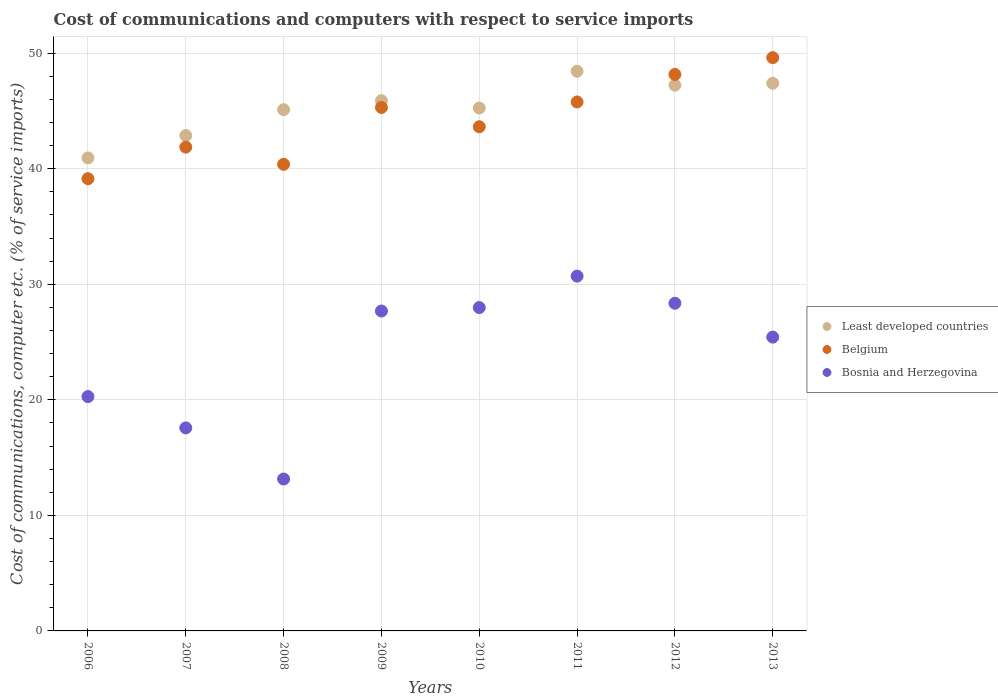Is the number of dotlines equal to the number of legend labels?
Your answer should be compact. Yes. What is the cost of communications and computers in Bosnia and Herzegovina in 2012?
Give a very brief answer. 28.36. Across all years, what is the maximum cost of communications and computers in Bosnia and Herzegovina?
Keep it short and to the point. 30.7. Across all years, what is the minimum cost of communications and computers in Bosnia and Herzegovina?
Your answer should be compact. 13.15. In which year was the cost of communications and computers in Bosnia and Herzegovina minimum?
Your response must be concise. 2008. What is the total cost of communications and computers in Bosnia and Herzegovina in the graph?
Your answer should be very brief. 191.15. What is the difference between the cost of communications and computers in Belgium in 2007 and that in 2011?
Provide a succinct answer. -3.91. What is the difference between the cost of communications and computers in Least developed countries in 2006 and the cost of communications and computers in Belgium in 2008?
Keep it short and to the point. 0.56. What is the average cost of communications and computers in Least developed countries per year?
Offer a very short reply. 45.39. In the year 2006, what is the difference between the cost of communications and computers in Least developed countries and cost of communications and computers in Bosnia and Herzegovina?
Ensure brevity in your answer.  20.66. What is the ratio of the cost of communications and computers in Bosnia and Herzegovina in 2007 to that in 2009?
Keep it short and to the point. 0.63. What is the difference between the highest and the second highest cost of communications and computers in Belgium?
Your answer should be compact. 1.46. What is the difference between the highest and the lowest cost of communications and computers in Bosnia and Herzegovina?
Give a very brief answer. 17.56. In how many years, is the cost of communications and computers in Least developed countries greater than the average cost of communications and computers in Least developed countries taken over all years?
Your answer should be very brief. 4. Is the sum of the cost of communications and computers in Belgium in 2008 and 2013 greater than the maximum cost of communications and computers in Least developed countries across all years?
Provide a succinct answer. Yes. Is it the case that in every year, the sum of the cost of communications and computers in Bosnia and Herzegovina and cost of communications and computers in Belgium  is greater than the cost of communications and computers in Least developed countries?
Give a very brief answer. Yes. Does the cost of communications and computers in Belgium monotonically increase over the years?
Give a very brief answer. No. Are the values on the major ticks of Y-axis written in scientific E-notation?
Offer a very short reply. No. Does the graph contain grids?
Your answer should be compact. Yes. Where does the legend appear in the graph?
Keep it short and to the point. Center right. How are the legend labels stacked?
Make the answer very short. Vertical. What is the title of the graph?
Provide a short and direct response. Cost of communications and computers with respect to service imports. Does "Gabon" appear as one of the legend labels in the graph?
Your answer should be compact. No. What is the label or title of the Y-axis?
Your answer should be compact. Cost of communications, computer etc. (% of service imports). What is the Cost of communications, computer etc. (% of service imports) in Least developed countries in 2006?
Keep it short and to the point. 40.94. What is the Cost of communications, computer etc. (% of service imports) of Belgium in 2006?
Offer a terse response. 39.14. What is the Cost of communications, computer etc. (% of service imports) of Bosnia and Herzegovina in 2006?
Your answer should be very brief. 20.28. What is the Cost of communications, computer etc. (% of service imports) in Least developed countries in 2007?
Make the answer very short. 42.87. What is the Cost of communications, computer etc. (% of service imports) of Belgium in 2007?
Give a very brief answer. 41.87. What is the Cost of communications, computer etc. (% of service imports) of Bosnia and Herzegovina in 2007?
Keep it short and to the point. 17.57. What is the Cost of communications, computer etc. (% of service imports) in Least developed countries in 2008?
Make the answer very short. 45.11. What is the Cost of communications, computer etc. (% of service imports) of Belgium in 2008?
Offer a very short reply. 40.38. What is the Cost of communications, computer etc. (% of service imports) of Bosnia and Herzegovina in 2008?
Your response must be concise. 13.15. What is the Cost of communications, computer etc. (% of service imports) in Least developed countries in 2009?
Your answer should be very brief. 45.89. What is the Cost of communications, computer etc. (% of service imports) of Belgium in 2009?
Offer a very short reply. 45.3. What is the Cost of communications, computer etc. (% of service imports) in Bosnia and Herzegovina in 2009?
Offer a terse response. 27.68. What is the Cost of communications, computer etc. (% of service imports) of Least developed countries in 2010?
Provide a short and direct response. 45.25. What is the Cost of communications, computer etc. (% of service imports) in Belgium in 2010?
Provide a succinct answer. 43.63. What is the Cost of communications, computer etc. (% of service imports) of Bosnia and Herzegovina in 2010?
Your answer should be very brief. 27.98. What is the Cost of communications, computer etc. (% of service imports) in Least developed countries in 2011?
Offer a very short reply. 48.43. What is the Cost of communications, computer etc. (% of service imports) in Belgium in 2011?
Provide a succinct answer. 45.78. What is the Cost of communications, computer etc. (% of service imports) of Bosnia and Herzegovina in 2011?
Keep it short and to the point. 30.7. What is the Cost of communications, computer etc. (% of service imports) of Least developed countries in 2012?
Ensure brevity in your answer.  47.23. What is the Cost of communications, computer etc. (% of service imports) in Belgium in 2012?
Provide a succinct answer. 48.16. What is the Cost of communications, computer etc. (% of service imports) in Bosnia and Herzegovina in 2012?
Offer a terse response. 28.36. What is the Cost of communications, computer etc. (% of service imports) of Least developed countries in 2013?
Offer a very short reply. 47.39. What is the Cost of communications, computer etc. (% of service imports) in Belgium in 2013?
Offer a very short reply. 49.61. What is the Cost of communications, computer etc. (% of service imports) in Bosnia and Herzegovina in 2013?
Make the answer very short. 25.43. Across all years, what is the maximum Cost of communications, computer etc. (% of service imports) of Least developed countries?
Your answer should be very brief. 48.43. Across all years, what is the maximum Cost of communications, computer etc. (% of service imports) in Belgium?
Provide a succinct answer. 49.61. Across all years, what is the maximum Cost of communications, computer etc. (% of service imports) of Bosnia and Herzegovina?
Your answer should be compact. 30.7. Across all years, what is the minimum Cost of communications, computer etc. (% of service imports) of Least developed countries?
Make the answer very short. 40.94. Across all years, what is the minimum Cost of communications, computer etc. (% of service imports) of Belgium?
Your response must be concise. 39.14. Across all years, what is the minimum Cost of communications, computer etc. (% of service imports) in Bosnia and Herzegovina?
Ensure brevity in your answer.  13.15. What is the total Cost of communications, computer etc. (% of service imports) of Least developed countries in the graph?
Your response must be concise. 363.11. What is the total Cost of communications, computer etc. (% of service imports) in Belgium in the graph?
Your response must be concise. 353.86. What is the total Cost of communications, computer etc. (% of service imports) of Bosnia and Herzegovina in the graph?
Your answer should be compact. 191.15. What is the difference between the Cost of communications, computer etc. (% of service imports) in Least developed countries in 2006 and that in 2007?
Your response must be concise. -1.93. What is the difference between the Cost of communications, computer etc. (% of service imports) in Belgium in 2006 and that in 2007?
Offer a terse response. -2.73. What is the difference between the Cost of communications, computer etc. (% of service imports) of Bosnia and Herzegovina in 2006 and that in 2007?
Ensure brevity in your answer.  2.71. What is the difference between the Cost of communications, computer etc. (% of service imports) in Least developed countries in 2006 and that in 2008?
Your response must be concise. -4.17. What is the difference between the Cost of communications, computer etc. (% of service imports) in Belgium in 2006 and that in 2008?
Your response must be concise. -1.25. What is the difference between the Cost of communications, computer etc. (% of service imports) of Bosnia and Herzegovina in 2006 and that in 2008?
Your answer should be compact. 7.13. What is the difference between the Cost of communications, computer etc. (% of service imports) in Least developed countries in 2006 and that in 2009?
Keep it short and to the point. -4.95. What is the difference between the Cost of communications, computer etc. (% of service imports) of Belgium in 2006 and that in 2009?
Offer a terse response. -6.17. What is the difference between the Cost of communications, computer etc. (% of service imports) in Bosnia and Herzegovina in 2006 and that in 2009?
Ensure brevity in your answer.  -7.4. What is the difference between the Cost of communications, computer etc. (% of service imports) in Least developed countries in 2006 and that in 2010?
Offer a terse response. -4.31. What is the difference between the Cost of communications, computer etc. (% of service imports) of Belgium in 2006 and that in 2010?
Your response must be concise. -4.5. What is the difference between the Cost of communications, computer etc. (% of service imports) in Bosnia and Herzegovina in 2006 and that in 2010?
Your response must be concise. -7.7. What is the difference between the Cost of communications, computer etc. (% of service imports) of Least developed countries in 2006 and that in 2011?
Provide a short and direct response. -7.5. What is the difference between the Cost of communications, computer etc. (% of service imports) in Belgium in 2006 and that in 2011?
Offer a very short reply. -6.64. What is the difference between the Cost of communications, computer etc. (% of service imports) in Bosnia and Herzegovina in 2006 and that in 2011?
Your response must be concise. -10.42. What is the difference between the Cost of communications, computer etc. (% of service imports) of Least developed countries in 2006 and that in 2012?
Make the answer very short. -6.29. What is the difference between the Cost of communications, computer etc. (% of service imports) in Belgium in 2006 and that in 2012?
Offer a terse response. -9.02. What is the difference between the Cost of communications, computer etc. (% of service imports) in Bosnia and Herzegovina in 2006 and that in 2012?
Provide a short and direct response. -8.08. What is the difference between the Cost of communications, computer etc. (% of service imports) of Least developed countries in 2006 and that in 2013?
Keep it short and to the point. -6.46. What is the difference between the Cost of communications, computer etc. (% of service imports) of Belgium in 2006 and that in 2013?
Offer a terse response. -10.48. What is the difference between the Cost of communications, computer etc. (% of service imports) of Bosnia and Herzegovina in 2006 and that in 2013?
Ensure brevity in your answer.  -5.15. What is the difference between the Cost of communications, computer etc. (% of service imports) of Least developed countries in 2007 and that in 2008?
Give a very brief answer. -2.24. What is the difference between the Cost of communications, computer etc. (% of service imports) of Belgium in 2007 and that in 2008?
Ensure brevity in your answer.  1.49. What is the difference between the Cost of communications, computer etc. (% of service imports) in Bosnia and Herzegovina in 2007 and that in 2008?
Keep it short and to the point. 4.42. What is the difference between the Cost of communications, computer etc. (% of service imports) of Least developed countries in 2007 and that in 2009?
Make the answer very short. -3.02. What is the difference between the Cost of communications, computer etc. (% of service imports) in Belgium in 2007 and that in 2009?
Your answer should be very brief. -3.43. What is the difference between the Cost of communications, computer etc. (% of service imports) of Bosnia and Herzegovina in 2007 and that in 2009?
Offer a very short reply. -10.11. What is the difference between the Cost of communications, computer etc. (% of service imports) of Least developed countries in 2007 and that in 2010?
Provide a short and direct response. -2.38. What is the difference between the Cost of communications, computer etc. (% of service imports) of Belgium in 2007 and that in 2010?
Your response must be concise. -1.76. What is the difference between the Cost of communications, computer etc. (% of service imports) of Bosnia and Herzegovina in 2007 and that in 2010?
Offer a very short reply. -10.41. What is the difference between the Cost of communications, computer etc. (% of service imports) of Least developed countries in 2007 and that in 2011?
Your answer should be compact. -5.56. What is the difference between the Cost of communications, computer etc. (% of service imports) of Belgium in 2007 and that in 2011?
Make the answer very short. -3.91. What is the difference between the Cost of communications, computer etc. (% of service imports) of Bosnia and Herzegovina in 2007 and that in 2011?
Make the answer very short. -13.13. What is the difference between the Cost of communications, computer etc. (% of service imports) in Least developed countries in 2007 and that in 2012?
Ensure brevity in your answer.  -4.36. What is the difference between the Cost of communications, computer etc. (% of service imports) in Belgium in 2007 and that in 2012?
Offer a terse response. -6.29. What is the difference between the Cost of communications, computer etc. (% of service imports) in Bosnia and Herzegovina in 2007 and that in 2012?
Provide a short and direct response. -10.79. What is the difference between the Cost of communications, computer etc. (% of service imports) of Least developed countries in 2007 and that in 2013?
Make the answer very short. -4.52. What is the difference between the Cost of communications, computer etc. (% of service imports) of Belgium in 2007 and that in 2013?
Your response must be concise. -7.74. What is the difference between the Cost of communications, computer etc. (% of service imports) in Bosnia and Herzegovina in 2007 and that in 2013?
Provide a short and direct response. -7.86. What is the difference between the Cost of communications, computer etc. (% of service imports) in Least developed countries in 2008 and that in 2009?
Give a very brief answer. -0.78. What is the difference between the Cost of communications, computer etc. (% of service imports) of Belgium in 2008 and that in 2009?
Keep it short and to the point. -4.92. What is the difference between the Cost of communications, computer etc. (% of service imports) in Bosnia and Herzegovina in 2008 and that in 2009?
Provide a succinct answer. -14.54. What is the difference between the Cost of communications, computer etc. (% of service imports) of Least developed countries in 2008 and that in 2010?
Your response must be concise. -0.14. What is the difference between the Cost of communications, computer etc. (% of service imports) in Belgium in 2008 and that in 2010?
Keep it short and to the point. -3.25. What is the difference between the Cost of communications, computer etc. (% of service imports) of Bosnia and Herzegovina in 2008 and that in 2010?
Provide a succinct answer. -14.84. What is the difference between the Cost of communications, computer etc. (% of service imports) in Least developed countries in 2008 and that in 2011?
Offer a very short reply. -3.32. What is the difference between the Cost of communications, computer etc. (% of service imports) of Belgium in 2008 and that in 2011?
Give a very brief answer. -5.39. What is the difference between the Cost of communications, computer etc. (% of service imports) of Bosnia and Herzegovina in 2008 and that in 2011?
Provide a short and direct response. -17.56. What is the difference between the Cost of communications, computer etc. (% of service imports) in Least developed countries in 2008 and that in 2012?
Offer a very short reply. -2.12. What is the difference between the Cost of communications, computer etc. (% of service imports) of Belgium in 2008 and that in 2012?
Make the answer very short. -7.77. What is the difference between the Cost of communications, computer etc. (% of service imports) in Bosnia and Herzegovina in 2008 and that in 2012?
Ensure brevity in your answer.  -15.21. What is the difference between the Cost of communications, computer etc. (% of service imports) in Least developed countries in 2008 and that in 2013?
Give a very brief answer. -2.29. What is the difference between the Cost of communications, computer etc. (% of service imports) in Belgium in 2008 and that in 2013?
Your response must be concise. -9.23. What is the difference between the Cost of communications, computer etc. (% of service imports) in Bosnia and Herzegovina in 2008 and that in 2013?
Offer a terse response. -12.28. What is the difference between the Cost of communications, computer etc. (% of service imports) of Least developed countries in 2009 and that in 2010?
Offer a terse response. 0.64. What is the difference between the Cost of communications, computer etc. (% of service imports) of Belgium in 2009 and that in 2010?
Provide a succinct answer. 1.67. What is the difference between the Cost of communications, computer etc. (% of service imports) in Bosnia and Herzegovina in 2009 and that in 2010?
Your response must be concise. -0.3. What is the difference between the Cost of communications, computer etc. (% of service imports) in Least developed countries in 2009 and that in 2011?
Offer a terse response. -2.55. What is the difference between the Cost of communications, computer etc. (% of service imports) in Belgium in 2009 and that in 2011?
Your answer should be compact. -0.47. What is the difference between the Cost of communications, computer etc. (% of service imports) in Bosnia and Herzegovina in 2009 and that in 2011?
Provide a short and direct response. -3.02. What is the difference between the Cost of communications, computer etc. (% of service imports) of Least developed countries in 2009 and that in 2012?
Give a very brief answer. -1.34. What is the difference between the Cost of communications, computer etc. (% of service imports) in Belgium in 2009 and that in 2012?
Provide a short and direct response. -2.85. What is the difference between the Cost of communications, computer etc. (% of service imports) in Bosnia and Herzegovina in 2009 and that in 2012?
Your response must be concise. -0.67. What is the difference between the Cost of communications, computer etc. (% of service imports) of Least developed countries in 2009 and that in 2013?
Your answer should be compact. -1.51. What is the difference between the Cost of communications, computer etc. (% of service imports) of Belgium in 2009 and that in 2013?
Keep it short and to the point. -4.31. What is the difference between the Cost of communications, computer etc. (% of service imports) of Bosnia and Herzegovina in 2009 and that in 2013?
Ensure brevity in your answer.  2.26. What is the difference between the Cost of communications, computer etc. (% of service imports) of Least developed countries in 2010 and that in 2011?
Ensure brevity in your answer.  -3.18. What is the difference between the Cost of communications, computer etc. (% of service imports) in Belgium in 2010 and that in 2011?
Keep it short and to the point. -2.14. What is the difference between the Cost of communications, computer etc. (% of service imports) of Bosnia and Herzegovina in 2010 and that in 2011?
Keep it short and to the point. -2.72. What is the difference between the Cost of communications, computer etc. (% of service imports) in Least developed countries in 2010 and that in 2012?
Keep it short and to the point. -1.98. What is the difference between the Cost of communications, computer etc. (% of service imports) in Belgium in 2010 and that in 2012?
Give a very brief answer. -4.52. What is the difference between the Cost of communications, computer etc. (% of service imports) of Bosnia and Herzegovina in 2010 and that in 2012?
Your answer should be compact. -0.37. What is the difference between the Cost of communications, computer etc. (% of service imports) in Least developed countries in 2010 and that in 2013?
Offer a very short reply. -2.14. What is the difference between the Cost of communications, computer etc. (% of service imports) in Belgium in 2010 and that in 2013?
Ensure brevity in your answer.  -5.98. What is the difference between the Cost of communications, computer etc. (% of service imports) in Bosnia and Herzegovina in 2010 and that in 2013?
Your answer should be very brief. 2.55. What is the difference between the Cost of communications, computer etc. (% of service imports) of Least developed countries in 2011 and that in 2012?
Ensure brevity in your answer.  1.21. What is the difference between the Cost of communications, computer etc. (% of service imports) of Belgium in 2011 and that in 2012?
Provide a succinct answer. -2.38. What is the difference between the Cost of communications, computer etc. (% of service imports) of Bosnia and Herzegovina in 2011 and that in 2012?
Your answer should be compact. 2.35. What is the difference between the Cost of communications, computer etc. (% of service imports) in Least developed countries in 2011 and that in 2013?
Your response must be concise. 1.04. What is the difference between the Cost of communications, computer etc. (% of service imports) in Belgium in 2011 and that in 2013?
Provide a succinct answer. -3.84. What is the difference between the Cost of communications, computer etc. (% of service imports) in Bosnia and Herzegovina in 2011 and that in 2013?
Offer a terse response. 5.28. What is the difference between the Cost of communications, computer etc. (% of service imports) in Least developed countries in 2012 and that in 2013?
Offer a terse response. -0.17. What is the difference between the Cost of communications, computer etc. (% of service imports) of Belgium in 2012 and that in 2013?
Your answer should be compact. -1.46. What is the difference between the Cost of communications, computer etc. (% of service imports) of Bosnia and Herzegovina in 2012 and that in 2013?
Your response must be concise. 2.93. What is the difference between the Cost of communications, computer etc. (% of service imports) in Least developed countries in 2006 and the Cost of communications, computer etc. (% of service imports) in Belgium in 2007?
Your response must be concise. -0.93. What is the difference between the Cost of communications, computer etc. (% of service imports) of Least developed countries in 2006 and the Cost of communications, computer etc. (% of service imports) of Bosnia and Herzegovina in 2007?
Ensure brevity in your answer.  23.37. What is the difference between the Cost of communications, computer etc. (% of service imports) in Belgium in 2006 and the Cost of communications, computer etc. (% of service imports) in Bosnia and Herzegovina in 2007?
Provide a succinct answer. 21.57. What is the difference between the Cost of communications, computer etc. (% of service imports) of Least developed countries in 2006 and the Cost of communications, computer etc. (% of service imports) of Belgium in 2008?
Keep it short and to the point. 0.56. What is the difference between the Cost of communications, computer etc. (% of service imports) in Least developed countries in 2006 and the Cost of communications, computer etc. (% of service imports) in Bosnia and Herzegovina in 2008?
Provide a short and direct response. 27.79. What is the difference between the Cost of communications, computer etc. (% of service imports) of Belgium in 2006 and the Cost of communications, computer etc. (% of service imports) of Bosnia and Herzegovina in 2008?
Provide a succinct answer. 25.99. What is the difference between the Cost of communications, computer etc. (% of service imports) of Least developed countries in 2006 and the Cost of communications, computer etc. (% of service imports) of Belgium in 2009?
Your answer should be compact. -4.36. What is the difference between the Cost of communications, computer etc. (% of service imports) of Least developed countries in 2006 and the Cost of communications, computer etc. (% of service imports) of Bosnia and Herzegovina in 2009?
Give a very brief answer. 13.25. What is the difference between the Cost of communications, computer etc. (% of service imports) in Belgium in 2006 and the Cost of communications, computer etc. (% of service imports) in Bosnia and Herzegovina in 2009?
Make the answer very short. 11.45. What is the difference between the Cost of communications, computer etc. (% of service imports) in Least developed countries in 2006 and the Cost of communications, computer etc. (% of service imports) in Belgium in 2010?
Your answer should be compact. -2.69. What is the difference between the Cost of communications, computer etc. (% of service imports) of Least developed countries in 2006 and the Cost of communications, computer etc. (% of service imports) of Bosnia and Herzegovina in 2010?
Provide a short and direct response. 12.96. What is the difference between the Cost of communications, computer etc. (% of service imports) in Belgium in 2006 and the Cost of communications, computer etc. (% of service imports) in Bosnia and Herzegovina in 2010?
Offer a terse response. 11.15. What is the difference between the Cost of communications, computer etc. (% of service imports) of Least developed countries in 2006 and the Cost of communications, computer etc. (% of service imports) of Belgium in 2011?
Keep it short and to the point. -4.84. What is the difference between the Cost of communications, computer etc. (% of service imports) of Least developed countries in 2006 and the Cost of communications, computer etc. (% of service imports) of Bosnia and Herzegovina in 2011?
Give a very brief answer. 10.23. What is the difference between the Cost of communications, computer etc. (% of service imports) in Belgium in 2006 and the Cost of communications, computer etc. (% of service imports) in Bosnia and Herzegovina in 2011?
Ensure brevity in your answer.  8.43. What is the difference between the Cost of communications, computer etc. (% of service imports) in Least developed countries in 2006 and the Cost of communications, computer etc. (% of service imports) in Belgium in 2012?
Your response must be concise. -7.22. What is the difference between the Cost of communications, computer etc. (% of service imports) of Least developed countries in 2006 and the Cost of communications, computer etc. (% of service imports) of Bosnia and Herzegovina in 2012?
Your response must be concise. 12.58. What is the difference between the Cost of communications, computer etc. (% of service imports) of Belgium in 2006 and the Cost of communications, computer etc. (% of service imports) of Bosnia and Herzegovina in 2012?
Your answer should be very brief. 10.78. What is the difference between the Cost of communications, computer etc. (% of service imports) of Least developed countries in 2006 and the Cost of communications, computer etc. (% of service imports) of Belgium in 2013?
Your answer should be very brief. -8.67. What is the difference between the Cost of communications, computer etc. (% of service imports) of Least developed countries in 2006 and the Cost of communications, computer etc. (% of service imports) of Bosnia and Herzegovina in 2013?
Ensure brevity in your answer.  15.51. What is the difference between the Cost of communications, computer etc. (% of service imports) of Belgium in 2006 and the Cost of communications, computer etc. (% of service imports) of Bosnia and Herzegovina in 2013?
Make the answer very short. 13.71. What is the difference between the Cost of communications, computer etc. (% of service imports) in Least developed countries in 2007 and the Cost of communications, computer etc. (% of service imports) in Belgium in 2008?
Make the answer very short. 2.49. What is the difference between the Cost of communications, computer etc. (% of service imports) in Least developed countries in 2007 and the Cost of communications, computer etc. (% of service imports) in Bosnia and Herzegovina in 2008?
Provide a succinct answer. 29.73. What is the difference between the Cost of communications, computer etc. (% of service imports) in Belgium in 2007 and the Cost of communications, computer etc. (% of service imports) in Bosnia and Herzegovina in 2008?
Your answer should be compact. 28.72. What is the difference between the Cost of communications, computer etc. (% of service imports) in Least developed countries in 2007 and the Cost of communications, computer etc. (% of service imports) in Belgium in 2009?
Your response must be concise. -2.43. What is the difference between the Cost of communications, computer etc. (% of service imports) of Least developed countries in 2007 and the Cost of communications, computer etc. (% of service imports) of Bosnia and Herzegovina in 2009?
Offer a very short reply. 15.19. What is the difference between the Cost of communications, computer etc. (% of service imports) in Belgium in 2007 and the Cost of communications, computer etc. (% of service imports) in Bosnia and Herzegovina in 2009?
Offer a very short reply. 14.18. What is the difference between the Cost of communications, computer etc. (% of service imports) in Least developed countries in 2007 and the Cost of communications, computer etc. (% of service imports) in Belgium in 2010?
Make the answer very short. -0.76. What is the difference between the Cost of communications, computer etc. (% of service imports) in Least developed countries in 2007 and the Cost of communications, computer etc. (% of service imports) in Bosnia and Herzegovina in 2010?
Offer a very short reply. 14.89. What is the difference between the Cost of communications, computer etc. (% of service imports) in Belgium in 2007 and the Cost of communications, computer etc. (% of service imports) in Bosnia and Herzegovina in 2010?
Provide a short and direct response. 13.89. What is the difference between the Cost of communications, computer etc. (% of service imports) of Least developed countries in 2007 and the Cost of communications, computer etc. (% of service imports) of Belgium in 2011?
Your answer should be very brief. -2.9. What is the difference between the Cost of communications, computer etc. (% of service imports) of Least developed countries in 2007 and the Cost of communications, computer etc. (% of service imports) of Bosnia and Herzegovina in 2011?
Make the answer very short. 12.17. What is the difference between the Cost of communications, computer etc. (% of service imports) in Belgium in 2007 and the Cost of communications, computer etc. (% of service imports) in Bosnia and Herzegovina in 2011?
Make the answer very short. 11.16. What is the difference between the Cost of communications, computer etc. (% of service imports) of Least developed countries in 2007 and the Cost of communications, computer etc. (% of service imports) of Belgium in 2012?
Provide a succinct answer. -5.28. What is the difference between the Cost of communications, computer etc. (% of service imports) in Least developed countries in 2007 and the Cost of communications, computer etc. (% of service imports) in Bosnia and Herzegovina in 2012?
Keep it short and to the point. 14.51. What is the difference between the Cost of communications, computer etc. (% of service imports) in Belgium in 2007 and the Cost of communications, computer etc. (% of service imports) in Bosnia and Herzegovina in 2012?
Offer a very short reply. 13.51. What is the difference between the Cost of communications, computer etc. (% of service imports) of Least developed countries in 2007 and the Cost of communications, computer etc. (% of service imports) of Belgium in 2013?
Provide a succinct answer. -6.74. What is the difference between the Cost of communications, computer etc. (% of service imports) in Least developed countries in 2007 and the Cost of communications, computer etc. (% of service imports) in Bosnia and Herzegovina in 2013?
Your answer should be very brief. 17.44. What is the difference between the Cost of communications, computer etc. (% of service imports) of Belgium in 2007 and the Cost of communications, computer etc. (% of service imports) of Bosnia and Herzegovina in 2013?
Provide a succinct answer. 16.44. What is the difference between the Cost of communications, computer etc. (% of service imports) in Least developed countries in 2008 and the Cost of communications, computer etc. (% of service imports) in Belgium in 2009?
Provide a succinct answer. -0.19. What is the difference between the Cost of communications, computer etc. (% of service imports) of Least developed countries in 2008 and the Cost of communications, computer etc. (% of service imports) of Bosnia and Herzegovina in 2009?
Ensure brevity in your answer.  17.42. What is the difference between the Cost of communications, computer etc. (% of service imports) in Belgium in 2008 and the Cost of communications, computer etc. (% of service imports) in Bosnia and Herzegovina in 2009?
Your answer should be compact. 12.7. What is the difference between the Cost of communications, computer etc. (% of service imports) of Least developed countries in 2008 and the Cost of communications, computer etc. (% of service imports) of Belgium in 2010?
Give a very brief answer. 1.48. What is the difference between the Cost of communications, computer etc. (% of service imports) of Least developed countries in 2008 and the Cost of communications, computer etc. (% of service imports) of Bosnia and Herzegovina in 2010?
Your response must be concise. 17.13. What is the difference between the Cost of communications, computer etc. (% of service imports) of Belgium in 2008 and the Cost of communications, computer etc. (% of service imports) of Bosnia and Herzegovina in 2010?
Give a very brief answer. 12.4. What is the difference between the Cost of communications, computer etc. (% of service imports) in Least developed countries in 2008 and the Cost of communications, computer etc. (% of service imports) in Belgium in 2011?
Offer a terse response. -0.67. What is the difference between the Cost of communications, computer etc. (% of service imports) of Least developed countries in 2008 and the Cost of communications, computer etc. (% of service imports) of Bosnia and Herzegovina in 2011?
Provide a succinct answer. 14.4. What is the difference between the Cost of communications, computer etc. (% of service imports) in Belgium in 2008 and the Cost of communications, computer etc. (% of service imports) in Bosnia and Herzegovina in 2011?
Offer a very short reply. 9.68. What is the difference between the Cost of communications, computer etc. (% of service imports) of Least developed countries in 2008 and the Cost of communications, computer etc. (% of service imports) of Belgium in 2012?
Provide a succinct answer. -3.05. What is the difference between the Cost of communications, computer etc. (% of service imports) in Least developed countries in 2008 and the Cost of communications, computer etc. (% of service imports) in Bosnia and Herzegovina in 2012?
Ensure brevity in your answer.  16.75. What is the difference between the Cost of communications, computer etc. (% of service imports) of Belgium in 2008 and the Cost of communications, computer etc. (% of service imports) of Bosnia and Herzegovina in 2012?
Give a very brief answer. 12.03. What is the difference between the Cost of communications, computer etc. (% of service imports) of Least developed countries in 2008 and the Cost of communications, computer etc. (% of service imports) of Belgium in 2013?
Offer a terse response. -4.5. What is the difference between the Cost of communications, computer etc. (% of service imports) in Least developed countries in 2008 and the Cost of communications, computer etc. (% of service imports) in Bosnia and Herzegovina in 2013?
Give a very brief answer. 19.68. What is the difference between the Cost of communications, computer etc. (% of service imports) of Belgium in 2008 and the Cost of communications, computer etc. (% of service imports) of Bosnia and Herzegovina in 2013?
Keep it short and to the point. 14.95. What is the difference between the Cost of communications, computer etc. (% of service imports) of Least developed countries in 2009 and the Cost of communications, computer etc. (% of service imports) of Belgium in 2010?
Provide a succinct answer. 2.25. What is the difference between the Cost of communications, computer etc. (% of service imports) in Least developed countries in 2009 and the Cost of communications, computer etc. (% of service imports) in Bosnia and Herzegovina in 2010?
Provide a short and direct response. 17.91. What is the difference between the Cost of communications, computer etc. (% of service imports) in Belgium in 2009 and the Cost of communications, computer etc. (% of service imports) in Bosnia and Herzegovina in 2010?
Your answer should be compact. 17.32. What is the difference between the Cost of communications, computer etc. (% of service imports) in Least developed countries in 2009 and the Cost of communications, computer etc. (% of service imports) in Belgium in 2011?
Keep it short and to the point. 0.11. What is the difference between the Cost of communications, computer etc. (% of service imports) in Least developed countries in 2009 and the Cost of communications, computer etc. (% of service imports) in Bosnia and Herzegovina in 2011?
Offer a terse response. 15.18. What is the difference between the Cost of communications, computer etc. (% of service imports) in Belgium in 2009 and the Cost of communications, computer etc. (% of service imports) in Bosnia and Herzegovina in 2011?
Offer a very short reply. 14.6. What is the difference between the Cost of communications, computer etc. (% of service imports) in Least developed countries in 2009 and the Cost of communications, computer etc. (% of service imports) in Belgium in 2012?
Give a very brief answer. -2.27. What is the difference between the Cost of communications, computer etc. (% of service imports) in Least developed countries in 2009 and the Cost of communications, computer etc. (% of service imports) in Bosnia and Herzegovina in 2012?
Offer a terse response. 17.53. What is the difference between the Cost of communications, computer etc. (% of service imports) in Belgium in 2009 and the Cost of communications, computer etc. (% of service imports) in Bosnia and Herzegovina in 2012?
Keep it short and to the point. 16.94. What is the difference between the Cost of communications, computer etc. (% of service imports) in Least developed countries in 2009 and the Cost of communications, computer etc. (% of service imports) in Belgium in 2013?
Make the answer very short. -3.72. What is the difference between the Cost of communications, computer etc. (% of service imports) of Least developed countries in 2009 and the Cost of communications, computer etc. (% of service imports) of Bosnia and Herzegovina in 2013?
Keep it short and to the point. 20.46. What is the difference between the Cost of communications, computer etc. (% of service imports) of Belgium in 2009 and the Cost of communications, computer etc. (% of service imports) of Bosnia and Herzegovina in 2013?
Ensure brevity in your answer.  19.87. What is the difference between the Cost of communications, computer etc. (% of service imports) in Least developed countries in 2010 and the Cost of communications, computer etc. (% of service imports) in Belgium in 2011?
Keep it short and to the point. -0.53. What is the difference between the Cost of communications, computer etc. (% of service imports) in Least developed countries in 2010 and the Cost of communications, computer etc. (% of service imports) in Bosnia and Herzegovina in 2011?
Provide a short and direct response. 14.55. What is the difference between the Cost of communications, computer etc. (% of service imports) of Belgium in 2010 and the Cost of communications, computer etc. (% of service imports) of Bosnia and Herzegovina in 2011?
Keep it short and to the point. 12.93. What is the difference between the Cost of communications, computer etc. (% of service imports) of Least developed countries in 2010 and the Cost of communications, computer etc. (% of service imports) of Belgium in 2012?
Your response must be concise. -2.91. What is the difference between the Cost of communications, computer etc. (% of service imports) of Least developed countries in 2010 and the Cost of communications, computer etc. (% of service imports) of Bosnia and Herzegovina in 2012?
Your answer should be very brief. 16.89. What is the difference between the Cost of communications, computer etc. (% of service imports) of Belgium in 2010 and the Cost of communications, computer etc. (% of service imports) of Bosnia and Herzegovina in 2012?
Make the answer very short. 15.28. What is the difference between the Cost of communications, computer etc. (% of service imports) in Least developed countries in 2010 and the Cost of communications, computer etc. (% of service imports) in Belgium in 2013?
Ensure brevity in your answer.  -4.36. What is the difference between the Cost of communications, computer etc. (% of service imports) of Least developed countries in 2010 and the Cost of communications, computer etc. (% of service imports) of Bosnia and Herzegovina in 2013?
Keep it short and to the point. 19.82. What is the difference between the Cost of communications, computer etc. (% of service imports) in Belgium in 2010 and the Cost of communications, computer etc. (% of service imports) in Bosnia and Herzegovina in 2013?
Your answer should be compact. 18.2. What is the difference between the Cost of communications, computer etc. (% of service imports) of Least developed countries in 2011 and the Cost of communications, computer etc. (% of service imports) of Belgium in 2012?
Ensure brevity in your answer.  0.28. What is the difference between the Cost of communications, computer etc. (% of service imports) in Least developed countries in 2011 and the Cost of communications, computer etc. (% of service imports) in Bosnia and Herzegovina in 2012?
Offer a terse response. 20.08. What is the difference between the Cost of communications, computer etc. (% of service imports) in Belgium in 2011 and the Cost of communications, computer etc. (% of service imports) in Bosnia and Herzegovina in 2012?
Your answer should be very brief. 17.42. What is the difference between the Cost of communications, computer etc. (% of service imports) of Least developed countries in 2011 and the Cost of communications, computer etc. (% of service imports) of Belgium in 2013?
Provide a short and direct response. -1.18. What is the difference between the Cost of communications, computer etc. (% of service imports) in Least developed countries in 2011 and the Cost of communications, computer etc. (% of service imports) in Bosnia and Herzegovina in 2013?
Your response must be concise. 23.01. What is the difference between the Cost of communications, computer etc. (% of service imports) in Belgium in 2011 and the Cost of communications, computer etc. (% of service imports) in Bosnia and Herzegovina in 2013?
Ensure brevity in your answer.  20.35. What is the difference between the Cost of communications, computer etc. (% of service imports) in Least developed countries in 2012 and the Cost of communications, computer etc. (% of service imports) in Belgium in 2013?
Keep it short and to the point. -2.38. What is the difference between the Cost of communications, computer etc. (% of service imports) of Least developed countries in 2012 and the Cost of communications, computer etc. (% of service imports) of Bosnia and Herzegovina in 2013?
Your answer should be very brief. 21.8. What is the difference between the Cost of communications, computer etc. (% of service imports) in Belgium in 2012 and the Cost of communications, computer etc. (% of service imports) in Bosnia and Herzegovina in 2013?
Your answer should be compact. 22.73. What is the average Cost of communications, computer etc. (% of service imports) of Least developed countries per year?
Your response must be concise. 45.39. What is the average Cost of communications, computer etc. (% of service imports) of Belgium per year?
Offer a terse response. 44.23. What is the average Cost of communications, computer etc. (% of service imports) of Bosnia and Herzegovina per year?
Your answer should be compact. 23.89. In the year 2006, what is the difference between the Cost of communications, computer etc. (% of service imports) of Least developed countries and Cost of communications, computer etc. (% of service imports) of Belgium?
Offer a very short reply. 1.8. In the year 2006, what is the difference between the Cost of communications, computer etc. (% of service imports) in Least developed countries and Cost of communications, computer etc. (% of service imports) in Bosnia and Herzegovina?
Provide a succinct answer. 20.66. In the year 2006, what is the difference between the Cost of communications, computer etc. (% of service imports) in Belgium and Cost of communications, computer etc. (% of service imports) in Bosnia and Herzegovina?
Ensure brevity in your answer.  18.86. In the year 2007, what is the difference between the Cost of communications, computer etc. (% of service imports) of Least developed countries and Cost of communications, computer etc. (% of service imports) of Belgium?
Your response must be concise. 1. In the year 2007, what is the difference between the Cost of communications, computer etc. (% of service imports) in Least developed countries and Cost of communications, computer etc. (% of service imports) in Bosnia and Herzegovina?
Make the answer very short. 25.3. In the year 2007, what is the difference between the Cost of communications, computer etc. (% of service imports) in Belgium and Cost of communications, computer etc. (% of service imports) in Bosnia and Herzegovina?
Keep it short and to the point. 24.3. In the year 2008, what is the difference between the Cost of communications, computer etc. (% of service imports) in Least developed countries and Cost of communications, computer etc. (% of service imports) in Belgium?
Give a very brief answer. 4.73. In the year 2008, what is the difference between the Cost of communications, computer etc. (% of service imports) of Least developed countries and Cost of communications, computer etc. (% of service imports) of Bosnia and Herzegovina?
Offer a terse response. 31.96. In the year 2008, what is the difference between the Cost of communications, computer etc. (% of service imports) of Belgium and Cost of communications, computer etc. (% of service imports) of Bosnia and Herzegovina?
Keep it short and to the point. 27.24. In the year 2009, what is the difference between the Cost of communications, computer etc. (% of service imports) of Least developed countries and Cost of communications, computer etc. (% of service imports) of Belgium?
Give a very brief answer. 0.59. In the year 2009, what is the difference between the Cost of communications, computer etc. (% of service imports) of Least developed countries and Cost of communications, computer etc. (% of service imports) of Bosnia and Herzegovina?
Give a very brief answer. 18.2. In the year 2009, what is the difference between the Cost of communications, computer etc. (% of service imports) in Belgium and Cost of communications, computer etc. (% of service imports) in Bosnia and Herzegovina?
Give a very brief answer. 17.62. In the year 2010, what is the difference between the Cost of communications, computer etc. (% of service imports) in Least developed countries and Cost of communications, computer etc. (% of service imports) in Belgium?
Your answer should be compact. 1.62. In the year 2010, what is the difference between the Cost of communications, computer etc. (% of service imports) in Least developed countries and Cost of communications, computer etc. (% of service imports) in Bosnia and Herzegovina?
Provide a short and direct response. 17.27. In the year 2010, what is the difference between the Cost of communications, computer etc. (% of service imports) in Belgium and Cost of communications, computer etc. (% of service imports) in Bosnia and Herzegovina?
Your answer should be very brief. 15.65. In the year 2011, what is the difference between the Cost of communications, computer etc. (% of service imports) of Least developed countries and Cost of communications, computer etc. (% of service imports) of Belgium?
Provide a succinct answer. 2.66. In the year 2011, what is the difference between the Cost of communications, computer etc. (% of service imports) of Least developed countries and Cost of communications, computer etc. (% of service imports) of Bosnia and Herzegovina?
Ensure brevity in your answer.  17.73. In the year 2011, what is the difference between the Cost of communications, computer etc. (% of service imports) in Belgium and Cost of communications, computer etc. (% of service imports) in Bosnia and Herzegovina?
Offer a very short reply. 15.07. In the year 2012, what is the difference between the Cost of communications, computer etc. (% of service imports) of Least developed countries and Cost of communications, computer etc. (% of service imports) of Belgium?
Give a very brief answer. -0.93. In the year 2012, what is the difference between the Cost of communications, computer etc. (% of service imports) of Least developed countries and Cost of communications, computer etc. (% of service imports) of Bosnia and Herzegovina?
Keep it short and to the point. 18.87. In the year 2012, what is the difference between the Cost of communications, computer etc. (% of service imports) of Belgium and Cost of communications, computer etc. (% of service imports) of Bosnia and Herzegovina?
Make the answer very short. 19.8. In the year 2013, what is the difference between the Cost of communications, computer etc. (% of service imports) in Least developed countries and Cost of communications, computer etc. (% of service imports) in Belgium?
Ensure brevity in your answer.  -2.22. In the year 2013, what is the difference between the Cost of communications, computer etc. (% of service imports) of Least developed countries and Cost of communications, computer etc. (% of service imports) of Bosnia and Herzegovina?
Offer a very short reply. 21.97. In the year 2013, what is the difference between the Cost of communications, computer etc. (% of service imports) of Belgium and Cost of communications, computer etc. (% of service imports) of Bosnia and Herzegovina?
Ensure brevity in your answer.  24.18. What is the ratio of the Cost of communications, computer etc. (% of service imports) of Least developed countries in 2006 to that in 2007?
Your response must be concise. 0.95. What is the ratio of the Cost of communications, computer etc. (% of service imports) of Belgium in 2006 to that in 2007?
Provide a succinct answer. 0.93. What is the ratio of the Cost of communications, computer etc. (% of service imports) in Bosnia and Herzegovina in 2006 to that in 2007?
Your answer should be compact. 1.15. What is the ratio of the Cost of communications, computer etc. (% of service imports) in Least developed countries in 2006 to that in 2008?
Your answer should be compact. 0.91. What is the ratio of the Cost of communications, computer etc. (% of service imports) in Belgium in 2006 to that in 2008?
Your answer should be very brief. 0.97. What is the ratio of the Cost of communications, computer etc. (% of service imports) in Bosnia and Herzegovina in 2006 to that in 2008?
Your answer should be very brief. 1.54. What is the ratio of the Cost of communications, computer etc. (% of service imports) in Least developed countries in 2006 to that in 2009?
Your answer should be very brief. 0.89. What is the ratio of the Cost of communications, computer etc. (% of service imports) in Belgium in 2006 to that in 2009?
Your answer should be very brief. 0.86. What is the ratio of the Cost of communications, computer etc. (% of service imports) of Bosnia and Herzegovina in 2006 to that in 2009?
Ensure brevity in your answer.  0.73. What is the ratio of the Cost of communications, computer etc. (% of service imports) in Least developed countries in 2006 to that in 2010?
Keep it short and to the point. 0.9. What is the ratio of the Cost of communications, computer etc. (% of service imports) of Belgium in 2006 to that in 2010?
Provide a short and direct response. 0.9. What is the ratio of the Cost of communications, computer etc. (% of service imports) in Bosnia and Herzegovina in 2006 to that in 2010?
Provide a succinct answer. 0.72. What is the ratio of the Cost of communications, computer etc. (% of service imports) of Least developed countries in 2006 to that in 2011?
Provide a short and direct response. 0.85. What is the ratio of the Cost of communications, computer etc. (% of service imports) in Belgium in 2006 to that in 2011?
Make the answer very short. 0.85. What is the ratio of the Cost of communications, computer etc. (% of service imports) of Bosnia and Herzegovina in 2006 to that in 2011?
Offer a very short reply. 0.66. What is the ratio of the Cost of communications, computer etc. (% of service imports) in Least developed countries in 2006 to that in 2012?
Keep it short and to the point. 0.87. What is the ratio of the Cost of communications, computer etc. (% of service imports) of Belgium in 2006 to that in 2012?
Give a very brief answer. 0.81. What is the ratio of the Cost of communications, computer etc. (% of service imports) in Bosnia and Herzegovina in 2006 to that in 2012?
Offer a very short reply. 0.72. What is the ratio of the Cost of communications, computer etc. (% of service imports) of Least developed countries in 2006 to that in 2013?
Your response must be concise. 0.86. What is the ratio of the Cost of communications, computer etc. (% of service imports) of Belgium in 2006 to that in 2013?
Your response must be concise. 0.79. What is the ratio of the Cost of communications, computer etc. (% of service imports) of Bosnia and Herzegovina in 2006 to that in 2013?
Your response must be concise. 0.8. What is the ratio of the Cost of communications, computer etc. (% of service imports) in Least developed countries in 2007 to that in 2008?
Your answer should be compact. 0.95. What is the ratio of the Cost of communications, computer etc. (% of service imports) in Belgium in 2007 to that in 2008?
Offer a very short reply. 1.04. What is the ratio of the Cost of communications, computer etc. (% of service imports) of Bosnia and Herzegovina in 2007 to that in 2008?
Offer a very short reply. 1.34. What is the ratio of the Cost of communications, computer etc. (% of service imports) in Least developed countries in 2007 to that in 2009?
Offer a very short reply. 0.93. What is the ratio of the Cost of communications, computer etc. (% of service imports) of Belgium in 2007 to that in 2009?
Offer a terse response. 0.92. What is the ratio of the Cost of communications, computer etc. (% of service imports) of Bosnia and Herzegovina in 2007 to that in 2009?
Your answer should be very brief. 0.63. What is the ratio of the Cost of communications, computer etc. (% of service imports) in Least developed countries in 2007 to that in 2010?
Keep it short and to the point. 0.95. What is the ratio of the Cost of communications, computer etc. (% of service imports) of Belgium in 2007 to that in 2010?
Offer a terse response. 0.96. What is the ratio of the Cost of communications, computer etc. (% of service imports) in Bosnia and Herzegovina in 2007 to that in 2010?
Offer a very short reply. 0.63. What is the ratio of the Cost of communications, computer etc. (% of service imports) of Least developed countries in 2007 to that in 2011?
Offer a very short reply. 0.89. What is the ratio of the Cost of communications, computer etc. (% of service imports) of Belgium in 2007 to that in 2011?
Your response must be concise. 0.91. What is the ratio of the Cost of communications, computer etc. (% of service imports) of Bosnia and Herzegovina in 2007 to that in 2011?
Make the answer very short. 0.57. What is the ratio of the Cost of communications, computer etc. (% of service imports) of Least developed countries in 2007 to that in 2012?
Provide a short and direct response. 0.91. What is the ratio of the Cost of communications, computer etc. (% of service imports) of Belgium in 2007 to that in 2012?
Offer a very short reply. 0.87. What is the ratio of the Cost of communications, computer etc. (% of service imports) in Bosnia and Herzegovina in 2007 to that in 2012?
Give a very brief answer. 0.62. What is the ratio of the Cost of communications, computer etc. (% of service imports) of Least developed countries in 2007 to that in 2013?
Give a very brief answer. 0.9. What is the ratio of the Cost of communications, computer etc. (% of service imports) in Belgium in 2007 to that in 2013?
Offer a very short reply. 0.84. What is the ratio of the Cost of communications, computer etc. (% of service imports) in Bosnia and Herzegovina in 2007 to that in 2013?
Give a very brief answer. 0.69. What is the ratio of the Cost of communications, computer etc. (% of service imports) of Belgium in 2008 to that in 2009?
Provide a succinct answer. 0.89. What is the ratio of the Cost of communications, computer etc. (% of service imports) in Bosnia and Herzegovina in 2008 to that in 2009?
Your answer should be very brief. 0.47. What is the ratio of the Cost of communications, computer etc. (% of service imports) of Least developed countries in 2008 to that in 2010?
Give a very brief answer. 1. What is the ratio of the Cost of communications, computer etc. (% of service imports) in Belgium in 2008 to that in 2010?
Your answer should be very brief. 0.93. What is the ratio of the Cost of communications, computer etc. (% of service imports) in Bosnia and Herzegovina in 2008 to that in 2010?
Your response must be concise. 0.47. What is the ratio of the Cost of communications, computer etc. (% of service imports) in Least developed countries in 2008 to that in 2011?
Give a very brief answer. 0.93. What is the ratio of the Cost of communications, computer etc. (% of service imports) in Belgium in 2008 to that in 2011?
Ensure brevity in your answer.  0.88. What is the ratio of the Cost of communications, computer etc. (% of service imports) in Bosnia and Herzegovina in 2008 to that in 2011?
Provide a short and direct response. 0.43. What is the ratio of the Cost of communications, computer etc. (% of service imports) in Least developed countries in 2008 to that in 2012?
Offer a terse response. 0.96. What is the ratio of the Cost of communications, computer etc. (% of service imports) of Belgium in 2008 to that in 2012?
Your answer should be compact. 0.84. What is the ratio of the Cost of communications, computer etc. (% of service imports) of Bosnia and Herzegovina in 2008 to that in 2012?
Give a very brief answer. 0.46. What is the ratio of the Cost of communications, computer etc. (% of service imports) of Least developed countries in 2008 to that in 2013?
Your response must be concise. 0.95. What is the ratio of the Cost of communications, computer etc. (% of service imports) of Belgium in 2008 to that in 2013?
Ensure brevity in your answer.  0.81. What is the ratio of the Cost of communications, computer etc. (% of service imports) of Bosnia and Herzegovina in 2008 to that in 2013?
Make the answer very short. 0.52. What is the ratio of the Cost of communications, computer etc. (% of service imports) in Least developed countries in 2009 to that in 2010?
Provide a succinct answer. 1.01. What is the ratio of the Cost of communications, computer etc. (% of service imports) in Belgium in 2009 to that in 2010?
Offer a terse response. 1.04. What is the ratio of the Cost of communications, computer etc. (% of service imports) of Bosnia and Herzegovina in 2009 to that in 2010?
Your answer should be compact. 0.99. What is the ratio of the Cost of communications, computer etc. (% of service imports) of Bosnia and Herzegovina in 2009 to that in 2011?
Provide a short and direct response. 0.9. What is the ratio of the Cost of communications, computer etc. (% of service imports) in Least developed countries in 2009 to that in 2012?
Your answer should be compact. 0.97. What is the ratio of the Cost of communications, computer etc. (% of service imports) of Belgium in 2009 to that in 2012?
Your answer should be very brief. 0.94. What is the ratio of the Cost of communications, computer etc. (% of service imports) of Bosnia and Herzegovina in 2009 to that in 2012?
Make the answer very short. 0.98. What is the ratio of the Cost of communications, computer etc. (% of service imports) of Least developed countries in 2009 to that in 2013?
Offer a terse response. 0.97. What is the ratio of the Cost of communications, computer etc. (% of service imports) in Belgium in 2009 to that in 2013?
Keep it short and to the point. 0.91. What is the ratio of the Cost of communications, computer etc. (% of service imports) of Bosnia and Herzegovina in 2009 to that in 2013?
Offer a terse response. 1.09. What is the ratio of the Cost of communications, computer etc. (% of service imports) of Least developed countries in 2010 to that in 2011?
Give a very brief answer. 0.93. What is the ratio of the Cost of communications, computer etc. (% of service imports) in Belgium in 2010 to that in 2011?
Provide a succinct answer. 0.95. What is the ratio of the Cost of communications, computer etc. (% of service imports) of Bosnia and Herzegovina in 2010 to that in 2011?
Give a very brief answer. 0.91. What is the ratio of the Cost of communications, computer etc. (% of service imports) of Least developed countries in 2010 to that in 2012?
Offer a very short reply. 0.96. What is the ratio of the Cost of communications, computer etc. (% of service imports) of Belgium in 2010 to that in 2012?
Offer a terse response. 0.91. What is the ratio of the Cost of communications, computer etc. (% of service imports) of Bosnia and Herzegovina in 2010 to that in 2012?
Offer a terse response. 0.99. What is the ratio of the Cost of communications, computer etc. (% of service imports) in Least developed countries in 2010 to that in 2013?
Your response must be concise. 0.95. What is the ratio of the Cost of communications, computer etc. (% of service imports) in Belgium in 2010 to that in 2013?
Ensure brevity in your answer.  0.88. What is the ratio of the Cost of communications, computer etc. (% of service imports) of Bosnia and Herzegovina in 2010 to that in 2013?
Your answer should be compact. 1.1. What is the ratio of the Cost of communications, computer etc. (% of service imports) of Least developed countries in 2011 to that in 2012?
Provide a succinct answer. 1.03. What is the ratio of the Cost of communications, computer etc. (% of service imports) of Belgium in 2011 to that in 2012?
Your response must be concise. 0.95. What is the ratio of the Cost of communications, computer etc. (% of service imports) of Bosnia and Herzegovina in 2011 to that in 2012?
Your answer should be very brief. 1.08. What is the ratio of the Cost of communications, computer etc. (% of service imports) of Least developed countries in 2011 to that in 2013?
Ensure brevity in your answer.  1.02. What is the ratio of the Cost of communications, computer etc. (% of service imports) in Belgium in 2011 to that in 2013?
Provide a short and direct response. 0.92. What is the ratio of the Cost of communications, computer etc. (% of service imports) in Bosnia and Herzegovina in 2011 to that in 2013?
Provide a succinct answer. 1.21. What is the ratio of the Cost of communications, computer etc. (% of service imports) of Belgium in 2012 to that in 2013?
Provide a succinct answer. 0.97. What is the ratio of the Cost of communications, computer etc. (% of service imports) in Bosnia and Herzegovina in 2012 to that in 2013?
Make the answer very short. 1.12. What is the difference between the highest and the second highest Cost of communications, computer etc. (% of service imports) in Least developed countries?
Give a very brief answer. 1.04. What is the difference between the highest and the second highest Cost of communications, computer etc. (% of service imports) in Belgium?
Offer a very short reply. 1.46. What is the difference between the highest and the second highest Cost of communications, computer etc. (% of service imports) of Bosnia and Herzegovina?
Offer a very short reply. 2.35. What is the difference between the highest and the lowest Cost of communications, computer etc. (% of service imports) of Least developed countries?
Provide a short and direct response. 7.5. What is the difference between the highest and the lowest Cost of communications, computer etc. (% of service imports) in Belgium?
Your response must be concise. 10.48. What is the difference between the highest and the lowest Cost of communications, computer etc. (% of service imports) in Bosnia and Herzegovina?
Provide a short and direct response. 17.56. 